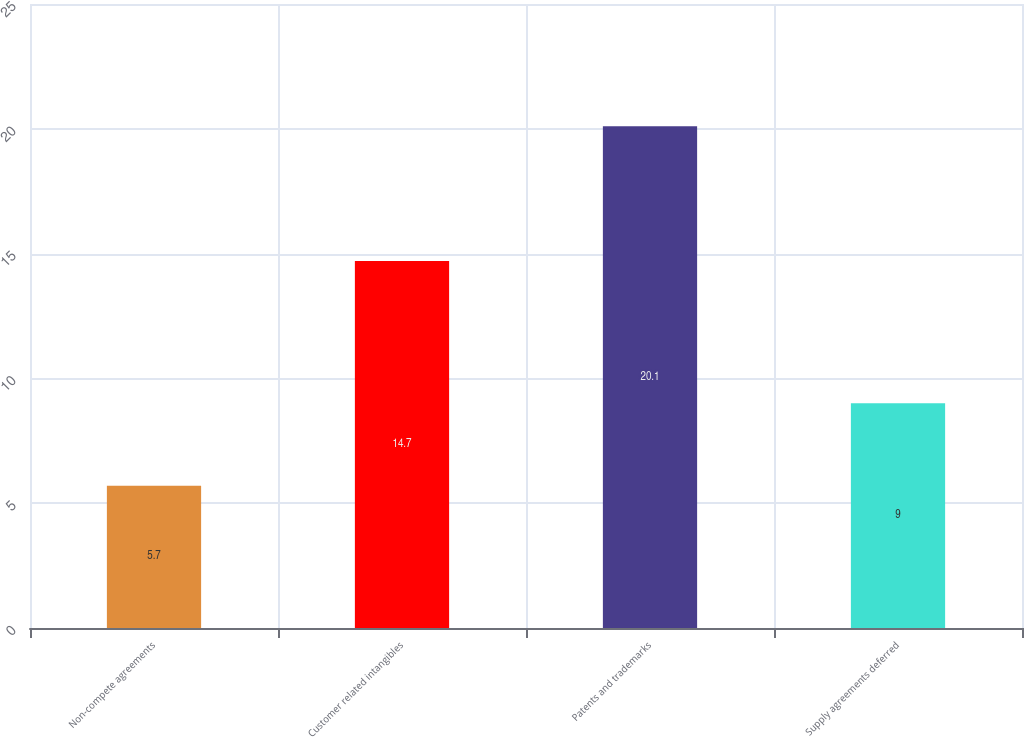Convert chart. <chart><loc_0><loc_0><loc_500><loc_500><bar_chart><fcel>Non-compete agreements<fcel>Customer related intangibles<fcel>Patents and trademarks<fcel>Supply agreements deferred<nl><fcel>5.7<fcel>14.7<fcel>20.1<fcel>9<nl></chart> 